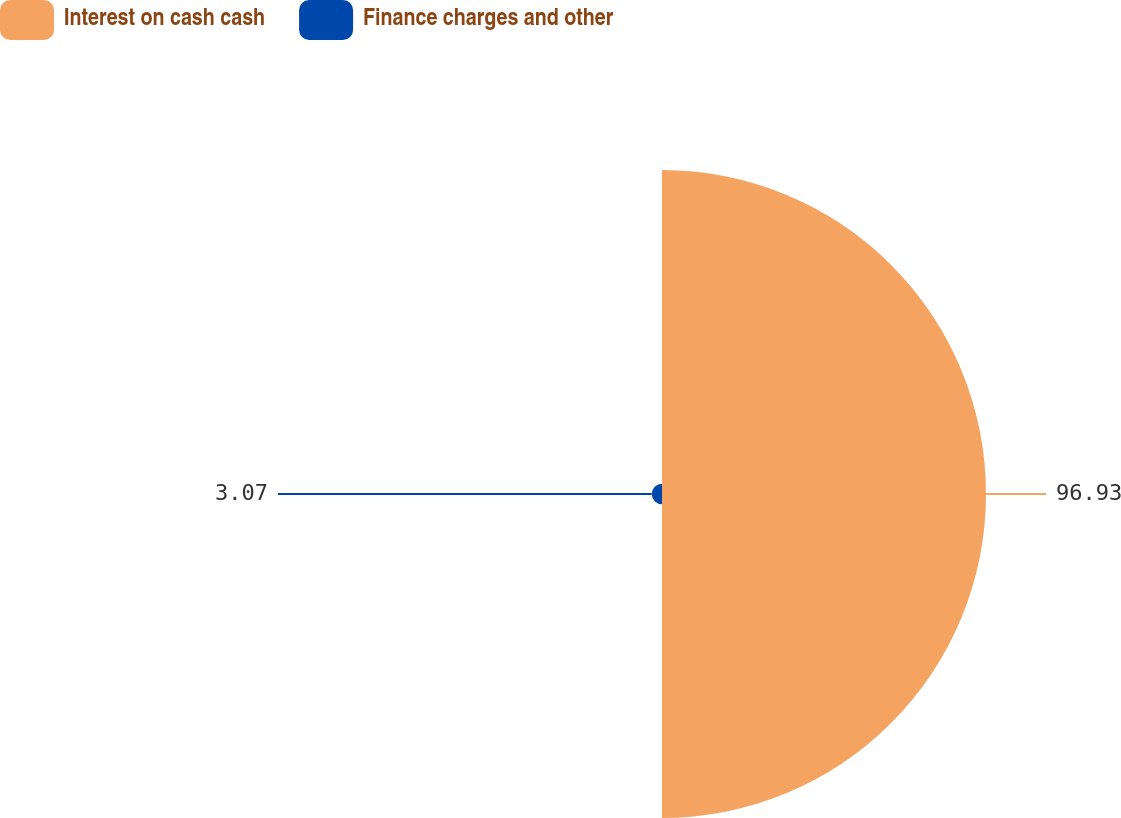Convert chart to OTSL. <chart><loc_0><loc_0><loc_500><loc_500><pie_chart><fcel>Interest on cash cash<fcel>Finance charges and other<nl><fcel>96.93%<fcel>3.07%<nl></chart> 